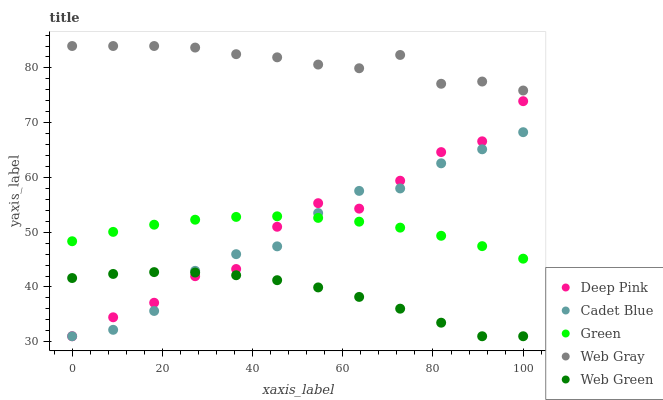Does Web Green have the minimum area under the curve?
Answer yes or no. Yes. Does Web Gray have the maximum area under the curve?
Answer yes or no. Yes. Does Deep Pink have the minimum area under the curve?
Answer yes or no. No. Does Deep Pink have the maximum area under the curve?
Answer yes or no. No. Is Green the smoothest?
Answer yes or no. Yes. Is Deep Pink the roughest?
Answer yes or no. Yes. Is Deep Pink the smoothest?
Answer yes or no. No. Is Green the roughest?
Answer yes or no. No. Does Cadet Blue have the lowest value?
Answer yes or no. Yes. Does Green have the lowest value?
Answer yes or no. No. Does Web Gray have the highest value?
Answer yes or no. Yes. Does Deep Pink have the highest value?
Answer yes or no. No. Is Deep Pink less than Web Gray?
Answer yes or no. Yes. Is Web Gray greater than Cadet Blue?
Answer yes or no. Yes. Does Deep Pink intersect Web Green?
Answer yes or no. Yes. Is Deep Pink less than Web Green?
Answer yes or no. No. Is Deep Pink greater than Web Green?
Answer yes or no. No. Does Deep Pink intersect Web Gray?
Answer yes or no. No. 